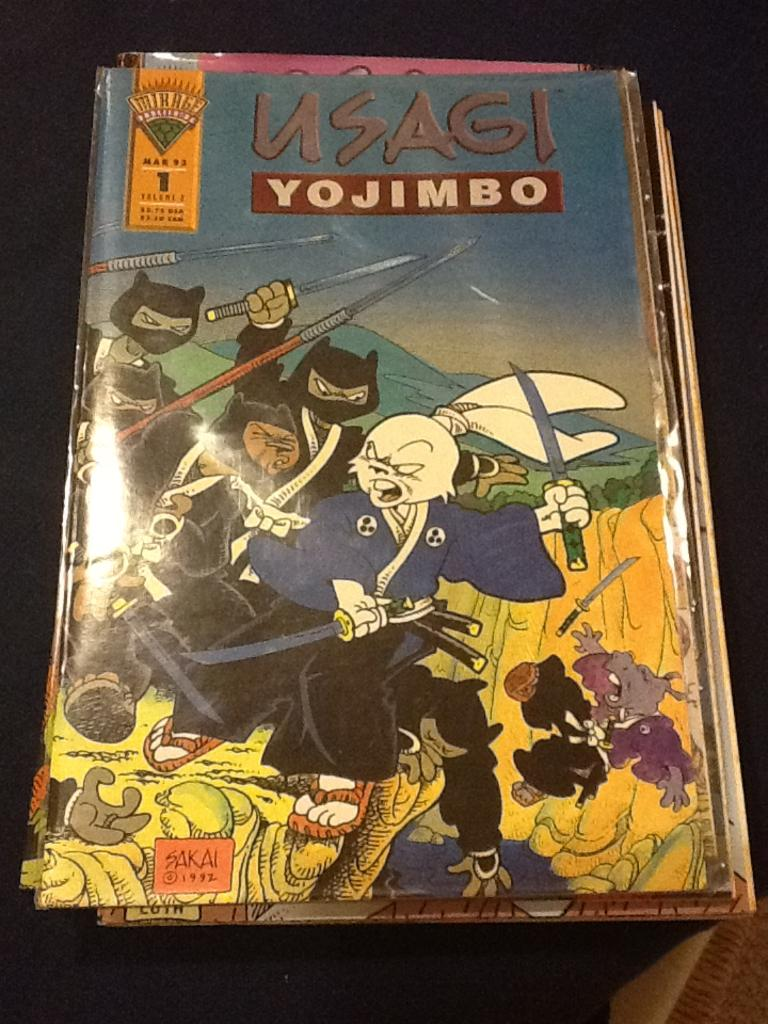<image>
Share a concise interpretation of the image provided. A samurai rabbit is on the front cove of the comic Usagi Yojimbo. 